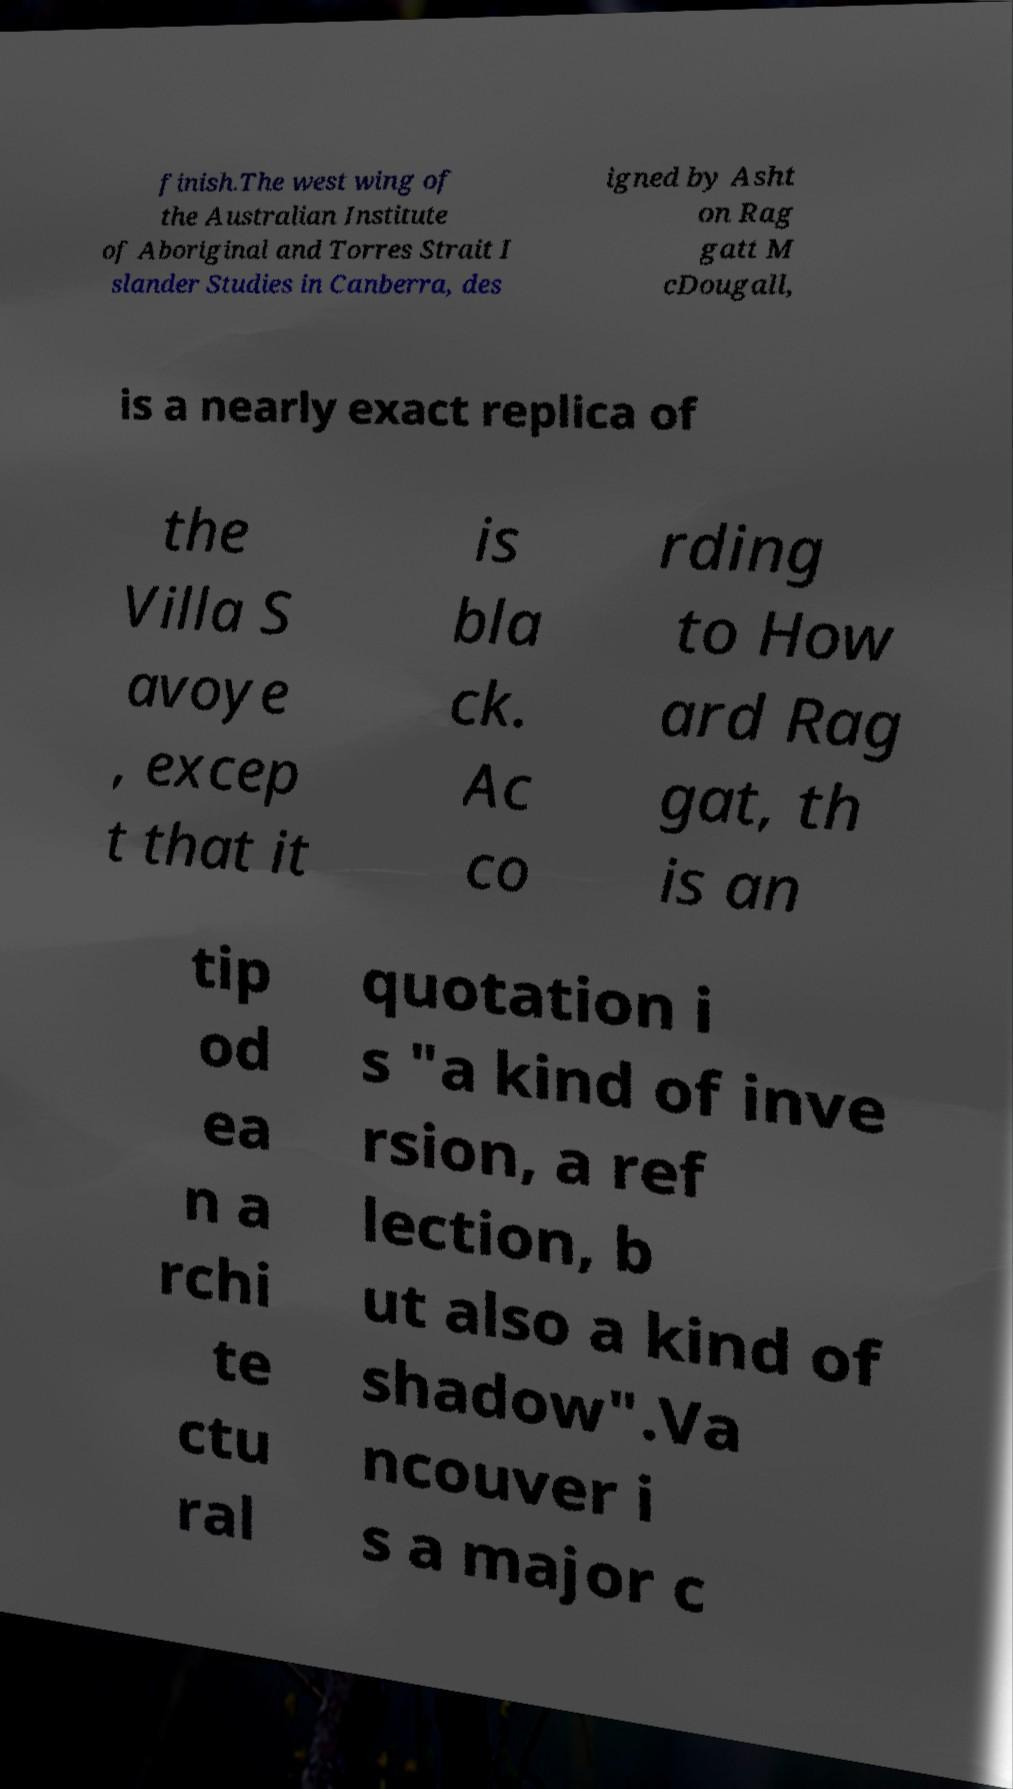Could you assist in decoding the text presented in this image and type it out clearly? finish.The west wing of the Australian Institute of Aboriginal and Torres Strait I slander Studies in Canberra, des igned by Asht on Rag gatt M cDougall, is a nearly exact replica of the Villa S avoye , excep t that it is bla ck. Ac co rding to How ard Rag gat, th is an tip od ea n a rchi te ctu ral quotation i s "a kind of inve rsion, a ref lection, b ut also a kind of shadow".Va ncouver i s a major c 